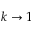Convert formula to latex. <formula><loc_0><loc_0><loc_500><loc_500>k \to 1</formula> 